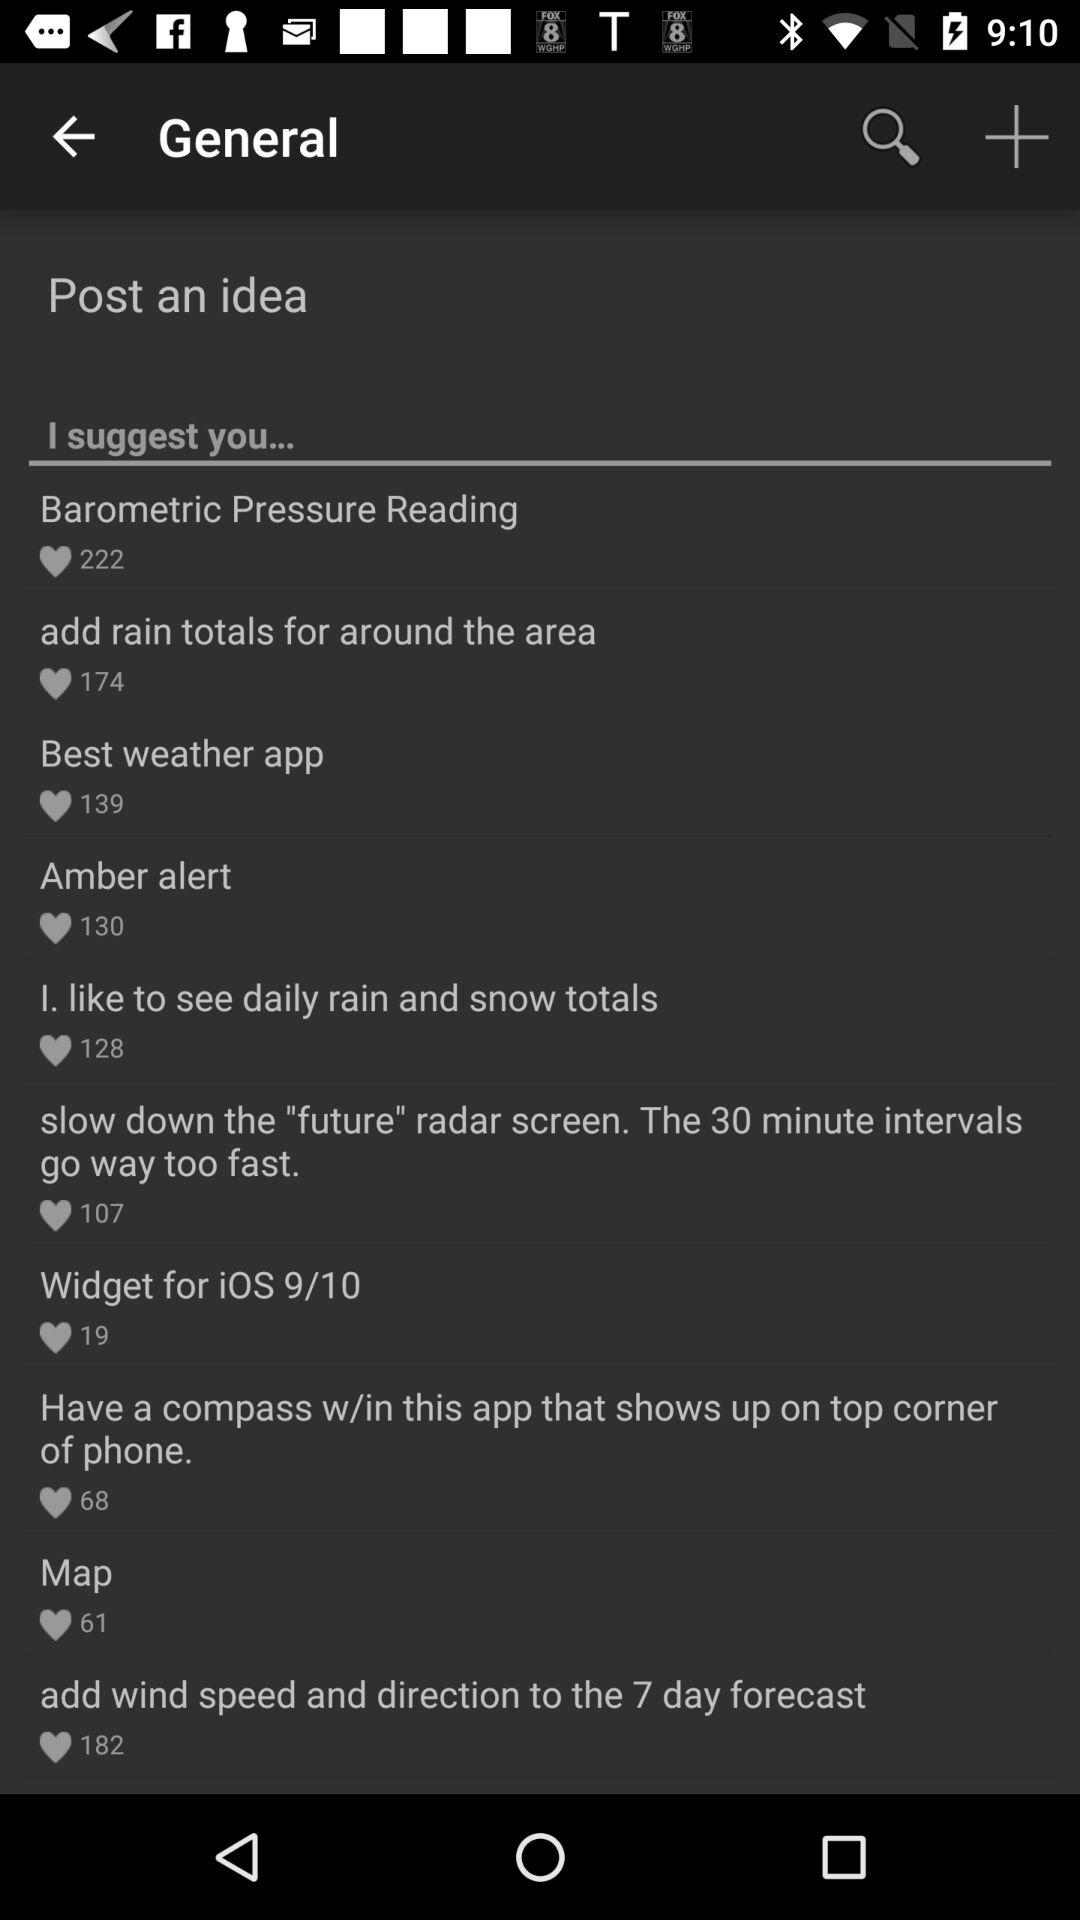How many likes did the "Amber alert" idea get? The "Amber alert" idea got 130 likes. 